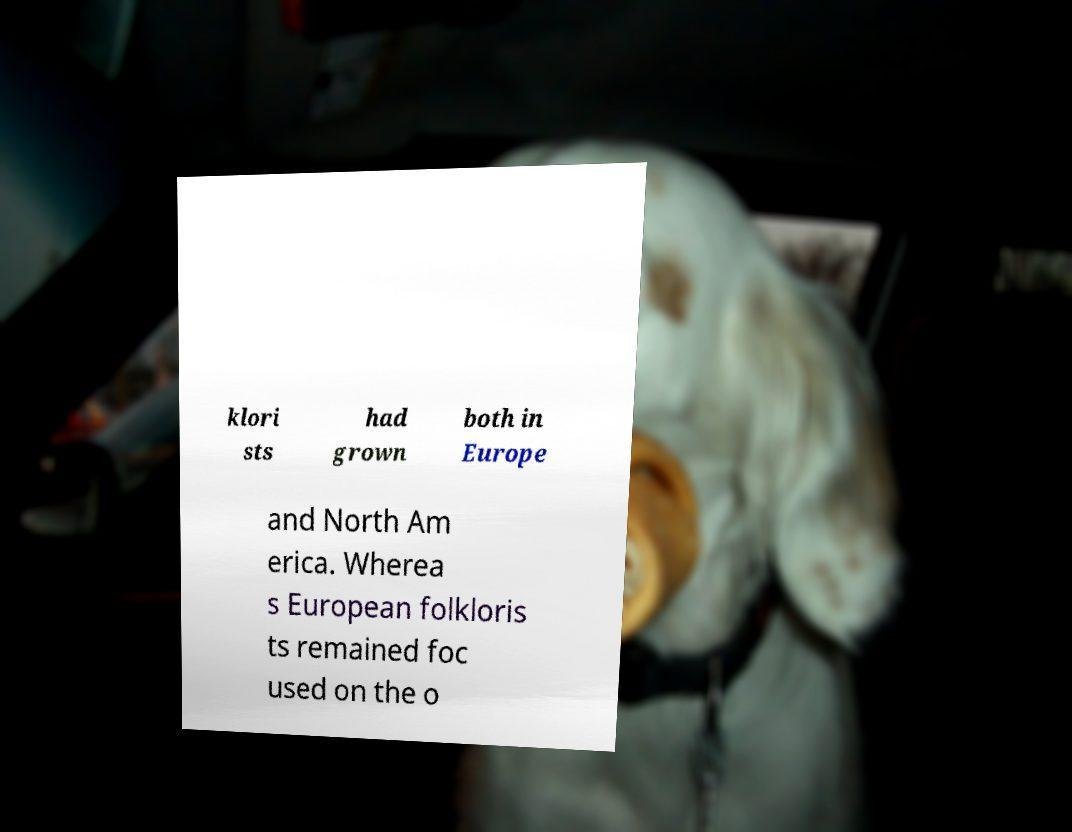I need the written content from this picture converted into text. Can you do that? klori sts had grown both in Europe and North Am erica. Wherea s European folkloris ts remained foc used on the o 